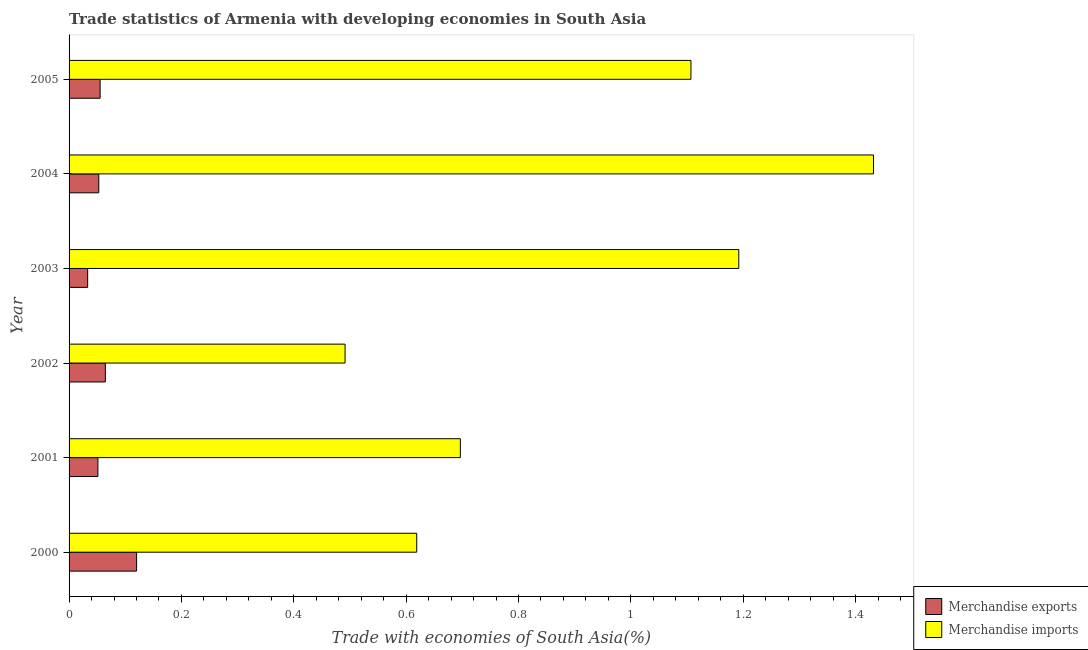How many groups of bars are there?
Ensure brevity in your answer.  6. How many bars are there on the 1st tick from the bottom?
Give a very brief answer. 2. What is the merchandise imports in 2000?
Your response must be concise. 0.62. Across all years, what is the maximum merchandise exports?
Keep it short and to the point. 0.12. Across all years, what is the minimum merchandise exports?
Your answer should be very brief. 0.03. In which year was the merchandise exports minimum?
Your answer should be compact. 2003. What is the total merchandise imports in the graph?
Your answer should be compact. 5.54. What is the difference between the merchandise imports in 2002 and that in 2004?
Your answer should be very brief. -0.94. What is the difference between the merchandise exports in 2005 and the merchandise imports in 2003?
Keep it short and to the point. -1.14. What is the average merchandise imports per year?
Make the answer very short. 0.92. In the year 2003, what is the difference between the merchandise exports and merchandise imports?
Ensure brevity in your answer.  -1.16. What is the ratio of the merchandise exports in 2000 to that in 2001?
Offer a very short reply. 2.34. What is the difference between the highest and the second highest merchandise exports?
Provide a succinct answer. 0.06. What is the difference between the highest and the lowest merchandise exports?
Offer a very short reply. 0.09. What does the 2nd bar from the top in 2004 represents?
Provide a short and direct response. Merchandise exports. Are all the bars in the graph horizontal?
Offer a terse response. Yes. How many years are there in the graph?
Your answer should be compact. 6. Does the graph contain any zero values?
Ensure brevity in your answer.  No. Where does the legend appear in the graph?
Make the answer very short. Bottom right. How many legend labels are there?
Offer a very short reply. 2. How are the legend labels stacked?
Offer a very short reply. Vertical. What is the title of the graph?
Ensure brevity in your answer.  Trade statistics of Armenia with developing economies in South Asia. Does "Female labourers" appear as one of the legend labels in the graph?
Your response must be concise. No. What is the label or title of the X-axis?
Offer a very short reply. Trade with economies of South Asia(%). What is the Trade with economies of South Asia(%) of Merchandise exports in 2000?
Ensure brevity in your answer.  0.12. What is the Trade with economies of South Asia(%) of Merchandise imports in 2000?
Your answer should be compact. 0.62. What is the Trade with economies of South Asia(%) in Merchandise exports in 2001?
Your answer should be compact. 0.05. What is the Trade with economies of South Asia(%) of Merchandise imports in 2001?
Your answer should be very brief. 0.7. What is the Trade with economies of South Asia(%) of Merchandise exports in 2002?
Give a very brief answer. 0.06. What is the Trade with economies of South Asia(%) in Merchandise imports in 2002?
Keep it short and to the point. 0.49. What is the Trade with economies of South Asia(%) in Merchandise exports in 2003?
Ensure brevity in your answer.  0.03. What is the Trade with economies of South Asia(%) of Merchandise imports in 2003?
Offer a terse response. 1.19. What is the Trade with economies of South Asia(%) in Merchandise exports in 2004?
Your response must be concise. 0.05. What is the Trade with economies of South Asia(%) in Merchandise imports in 2004?
Your answer should be very brief. 1.43. What is the Trade with economies of South Asia(%) in Merchandise exports in 2005?
Provide a short and direct response. 0.06. What is the Trade with economies of South Asia(%) of Merchandise imports in 2005?
Keep it short and to the point. 1.11. Across all years, what is the maximum Trade with economies of South Asia(%) of Merchandise exports?
Offer a very short reply. 0.12. Across all years, what is the maximum Trade with economies of South Asia(%) in Merchandise imports?
Make the answer very short. 1.43. Across all years, what is the minimum Trade with economies of South Asia(%) in Merchandise exports?
Give a very brief answer. 0.03. Across all years, what is the minimum Trade with economies of South Asia(%) in Merchandise imports?
Make the answer very short. 0.49. What is the total Trade with economies of South Asia(%) of Merchandise exports in the graph?
Your response must be concise. 0.38. What is the total Trade with economies of South Asia(%) of Merchandise imports in the graph?
Offer a terse response. 5.54. What is the difference between the Trade with economies of South Asia(%) of Merchandise exports in 2000 and that in 2001?
Provide a succinct answer. 0.07. What is the difference between the Trade with economies of South Asia(%) of Merchandise imports in 2000 and that in 2001?
Offer a terse response. -0.08. What is the difference between the Trade with economies of South Asia(%) of Merchandise exports in 2000 and that in 2002?
Offer a very short reply. 0.06. What is the difference between the Trade with economies of South Asia(%) in Merchandise imports in 2000 and that in 2002?
Make the answer very short. 0.13. What is the difference between the Trade with economies of South Asia(%) in Merchandise exports in 2000 and that in 2003?
Ensure brevity in your answer.  0.09. What is the difference between the Trade with economies of South Asia(%) in Merchandise imports in 2000 and that in 2003?
Offer a terse response. -0.57. What is the difference between the Trade with economies of South Asia(%) of Merchandise exports in 2000 and that in 2004?
Your answer should be compact. 0.07. What is the difference between the Trade with economies of South Asia(%) in Merchandise imports in 2000 and that in 2004?
Make the answer very short. -0.81. What is the difference between the Trade with economies of South Asia(%) in Merchandise exports in 2000 and that in 2005?
Provide a succinct answer. 0.06. What is the difference between the Trade with economies of South Asia(%) of Merchandise imports in 2000 and that in 2005?
Provide a short and direct response. -0.49. What is the difference between the Trade with economies of South Asia(%) of Merchandise exports in 2001 and that in 2002?
Make the answer very short. -0.01. What is the difference between the Trade with economies of South Asia(%) of Merchandise imports in 2001 and that in 2002?
Give a very brief answer. 0.21. What is the difference between the Trade with economies of South Asia(%) in Merchandise exports in 2001 and that in 2003?
Keep it short and to the point. 0.02. What is the difference between the Trade with economies of South Asia(%) of Merchandise imports in 2001 and that in 2003?
Ensure brevity in your answer.  -0.5. What is the difference between the Trade with economies of South Asia(%) of Merchandise exports in 2001 and that in 2004?
Give a very brief answer. -0. What is the difference between the Trade with economies of South Asia(%) of Merchandise imports in 2001 and that in 2004?
Your answer should be compact. -0.74. What is the difference between the Trade with economies of South Asia(%) of Merchandise exports in 2001 and that in 2005?
Give a very brief answer. -0. What is the difference between the Trade with economies of South Asia(%) of Merchandise imports in 2001 and that in 2005?
Make the answer very short. -0.41. What is the difference between the Trade with economies of South Asia(%) in Merchandise exports in 2002 and that in 2003?
Provide a succinct answer. 0.03. What is the difference between the Trade with economies of South Asia(%) of Merchandise imports in 2002 and that in 2003?
Make the answer very short. -0.7. What is the difference between the Trade with economies of South Asia(%) of Merchandise exports in 2002 and that in 2004?
Ensure brevity in your answer.  0.01. What is the difference between the Trade with economies of South Asia(%) in Merchandise imports in 2002 and that in 2004?
Offer a very short reply. -0.94. What is the difference between the Trade with economies of South Asia(%) in Merchandise exports in 2002 and that in 2005?
Provide a succinct answer. 0.01. What is the difference between the Trade with economies of South Asia(%) of Merchandise imports in 2002 and that in 2005?
Give a very brief answer. -0.62. What is the difference between the Trade with economies of South Asia(%) of Merchandise exports in 2003 and that in 2004?
Offer a terse response. -0.02. What is the difference between the Trade with economies of South Asia(%) of Merchandise imports in 2003 and that in 2004?
Your response must be concise. -0.24. What is the difference between the Trade with economies of South Asia(%) of Merchandise exports in 2003 and that in 2005?
Your answer should be very brief. -0.02. What is the difference between the Trade with economies of South Asia(%) of Merchandise imports in 2003 and that in 2005?
Offer a very short reply. 0.09. What is the difference between the Trade with economies of South Asia(%) in Merchandise exports in 2004 and that in 2005?
Provide a short and direct response. -0. What is the difference between the Trade with economies of South Asia(%) of Merchandise imports in 2004 and that in 2005?
Your response must be concise. 0.33. What is the difference between the Trade with economies of South Asia(%) in Merchandise exports in 2000 and the Trade with economies of South Asia(%) in Merchandise imports in 2001?
Your response must be concise. -0.58. What is the difference between the Trade with economies of South Asia(%) of Merchandise exports in 2000 and the Trade with economies of South Asia(%) of Merchandise imports in 2002?
Your answer should be compact. -0.37. What is the difference between the Trade with economies of South Asia(%) of Merchandise exports in 2000 and the Trade with economies of South Asia(%) of Merchandise imports in 2003?
Ensure brevity in your answer.  -1.07. What is the difference between the Trade with economies of South Asia(%) in Merchandise exports in 2000 and the Trade with economies of South Asia(%) in Merchandise imports in 2004?
Provide a short and direct response. -1.31. What is the difference between the Trade with economies of South Asia(%) of Merchandise exports in 2000 and the Trade with economies of South Asia(%) of Merchandise imports in 2005?
Ensure brevity in your answer.  -0.99. What is the difference between the Trade with economies of South Asia(%) in Merchandise exports in 2001 and the Trade with economies of South Asia(%) in Merchandise imports in 2002?
Provide a short and direct response. -0.44. What is the difference between the Trade with economies of South Asia(%) of Merchandise exports in 2001 and the Trade with economies of South Asia(%) of Merchandise imports in 2003?
Provide a succinct answer. -1.14. What is the difference between the Trade with economies of South Asia(%) in Merchandise exports in 2001 and the Trade with economies of South Asia(%) in Merchandise imports in 2004?
Give a very brief answer. -1.38. What is the difference between the Trade with economies of South Asia(%) in Merchandise exports in 2001 and the Trade with economies of South Asia(%) in Merchandise imports in 2005?
Offer a very short reply. -1.06. What is the difference between the Trade with economies of South Asia(%) in Merchandise exports in 2002 and the Trade with economies of South Asia(%) in Merchandise imports in 2003?
Give a very brief answer. -1.13. What is the difference between the Trade with economies of South Asia(%) of Merchandise exports in 2002 and the Trade with economies of South Asia(%) of Merchandise imports in 2004?
Provide a short and direct response. -1.37. What is the difference between the Trade with economies of South Asia(%) of Merchandise exports in 2002 and the Trade with economies of South Asia(%) of Merchandise imports in 2005?
Ensure brevity in your answer.  -1.04. What is the difference between the Trade with economies of South Asia(%) of Merchandise exports in 2003 and the Trade with economies of South Asia(%) of Merchandise imports in 2004?
Your response must be concise. -1.4. What is the difference between the Trade with economies of South Asia(%) of Merchandise exports in 2003 and the Trade with economies of South Asia(%) of Merchandise imports in 2005?
Provide a succinct answer. -1.07. What is the difference between the Trade with economies of South Asia(%) in Merchandise exports in 2004 and the Trade with economies of South Asia(%) in Merchandise imports in 2005?
Keep it short and to the point. -1.05. What is the average Trade with economies of South Asia(%) in Merchandise exports per year?
Ensure brevity in your answer.  0.06. What is the average Trade with economies of South Asia(%) of Merchandise imports per year?
Offer a very short reply. 0.92. In the year 2000, what is the difference between the Trade with economies of South Asia(%) in Merchandise exports and Trade with economies of South Asia(%) in Merchandise imports?
Make the answer very short. -0.5. In the year 2001, what is the difference between the Trade with economies of South Asia(%) of Merchandise exports and Trade with economies of South Asia(%) of Merchandise imports?
Provide a short and direct response. -0.65. In the year 2002, what is the difference between the Trade with economies of South Asia(%) of Merchandise exports and Trade with economies of South Asia(%) of Merchandise imports?
Keep it short and to the point. -0.43. In the year 2003, what is the difference between the Trade with economies of South Asia(%) of Merchandise exports and Trade with economies of South Asia(%) of Merchandise imports?
Offer a very short reply. -1.16. In the year 2004, what is the difference between the Trade with economies of South Asia(%) of Merchandise exports and Trade with economies of South Asia(%) of Merchandise imports?
Your answer should be compact. -1.38. In the year 2005, what is the difference between the Trade with economies of South Asia(%) of Merchandise exports and Trade with economies of South Asia(%) of Merchandise imports?
Give a very brief answer. -1.05. What is the ratio of the Trade with economies of South Asia(%) in Merchandise exports in 2000 to that in 2001?
Ensure brevity in your answer.  2.34. What is the ratio of the Trade with economies of South Asia(%) of Merchandise imports in 2000 to that in 2001?
Your response must be concise. 0.89. What is the ratio of the Trade with economies of South Asia(%) of Merchandise exports in 2000 to that in 2002?
Provide a succinct answer. 1.86. What is the ratio of the Trade with economies of South Asia(%) of Merchandise imports in 2000 to that in 2002?
Keep it short and to the point. 1.26. What is the ratio of the Trade with economies of South Asia(%) in Merchandise exports in 2000 to that in 2003?
Provide a short and direct response. 3.63. What is the ratio of the Trade with economies of South Asia(%) in Merchandise imports in 2000 to that in 2003?
Provide a succinct answer. 0.52. What is the ratio of the Trade with economies of South Asia(%) of Merchandise exports in 2000 to that in 2004?
Your answer should be compact. 2.27. What is the ratio of the Trade with economies of South Asia(%) in Merchandise imports in 2000 to that in 2004?
Offer a terse response. 0.43. What is the ratio of the Trade with economies of South Asia(%) of Merchandise exports in 2000 to that in 2005?
Your answer should be compact. 2.17. What is the ratio of the Trade with economies of South Asia(%) of Merchandise imports in 2000 to that in 2005?
Offer a very short reply. 0.56. What is the ratio of the Trade with economies of South Asia(%) of Merchandise exports in 2001 to that in 2002?
Keep it short and to the point. 0.79. What is the ratio of the Trade with economies of South Asia(%) in Merchandise imports in 2001 to that in 2002?
Keep it short and to the point. 1.42. What is the ratio of the Trade with economies of South Asia(%) of Merchandise exports in 2001 to that in 2003?
Your response must be concise. 1.55. What is the ratio of the Trade with economies of South Asia(%) of Merchandise imports in 2001 to that in 2003?
Offer a very short reply. 0.58. What is the ratio of the Trade with economies of South Asia(%) in Merchandise exports in 2001 to that in 2004?
Your response must be concise. 0.97. What is the ratio of the Trade with economies of South Asia(%) in Merchandise imports in 2001 to that in 2004?
Your response must be concise. 0.49. What is the ratio of the Trade with economies of South Asia(%) in Merchandise exports in 2001 to that in 2005?
Offer a very short reply. 0.93. What is the ratio of the Trade with economies of South Asia(%) of Merchandise imports in 2001 to that in 2005?
Offer a very short reply. 0.63. What is the ratio of the Trade with economies of South Asia(%) of Merchandise exports in 2002 to that in 2003?
Your answer should be very brief. 1.95. What is the ratio of the Trade with economies of South Asia(%) of Merchandise imports in 2002 to that in 2003?
Your answer should be compact. 0.41. What is the ratio of the Trade with economies of South Asia(%) in Merchandise exports in 2002 to that in 2004?
Provide a succinct answer. 1.22. What is the ratio of the Trade with economies of South Asia(%) in Merchandise imports in 2002 to that in 2004?
Give a very brief answer. 0.34. What is the ratio of the Trade with economies of South Asia(%) in Merchandise exports in 2002 to that in 2005?
Keep it short and to the point. 1.17. What is the ratio of the Trade with economies of South Asia(%) in Merchandise imports in 2002 to that in 2005?
Provide a succinct answer. 0.44. What is the ratio of the Trade with economies of South Asia(%) of Merchandise exports in 2003 to that in 2004?
Your response must be concise. 0.63. What is the ratio of the Trade with economies of South Asia(%) in Merchandise imports in 2003 to that in 2004?
Provide a succinct answer. 0.83. What is the ratio of the Trade with economies of South Asia(%) in Merchandise exports in 2003 to that in 2005?
Offer a very short reply. 0.6. What is the ratio of the Trade with economies of South Asia(%) of Merchandise imports in 2003 to that in 2005?
Provide a succinct answer. 1.08. What is the ratio of the Trade with economies of South Asia(%) in Merchandise exports in 2004 to that in 2005?
Ensure brevity in your answer.  0.96. What is the ratio of the Trade with economies of South Asia(%) of Merchandise imports in 2004 to that in 2005?
Provide a short and direct response. 1.29. What is the difference between the highest and the second highest Trade with economies of South Asia(%) of Merchandise exports?
Offer a very short reply. 0.06. What is the difference between the highest and the second highest Trade with economies of South Asia(%) of Merchandise imports?
Provide a succinct answer. 0.24. What is the difference between the highest and the lowest Trade with economies of South Asia(%) in Merchandise exports?
Offer a very short reply. 0.09. What is the difference between the highest and the lowest Trade with economies of South Asia(%) of Merchandise imports?
Give a very brief answer. 0.94. 